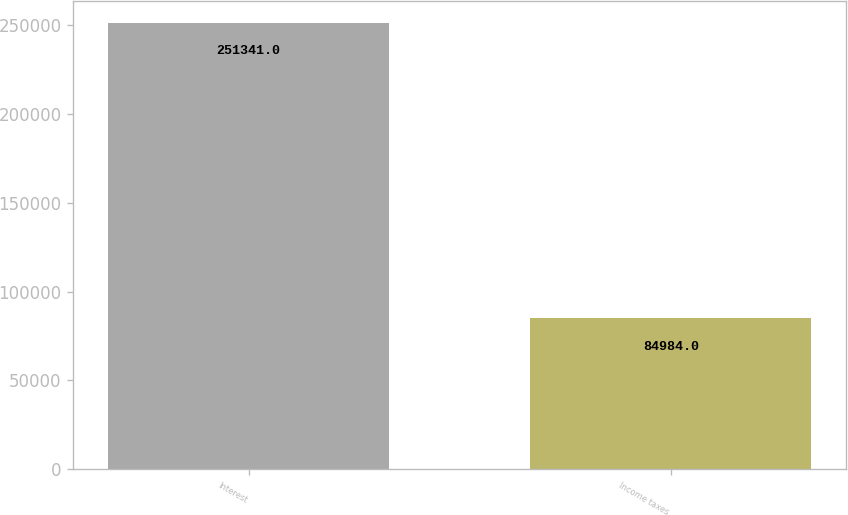Convert chart. <chart><loc_0><loc_0><loc_500><loc_500><bar_chart><fcel>Interest<fcel>Income taxes<nl><fcel>251341<fcel>84984<nl></chart> 